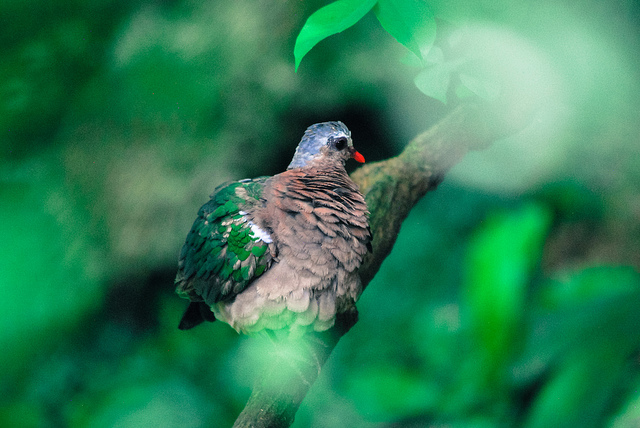<image>What kind of bird is this? I don't know what kind of bird this is. It could be a raven, finch, pheasant, pigeon, or duck. What kind of bird is this? I don't know what kind of bird is this. It can be seen as a raven, finch, pheasant, pigeon, or duck. 